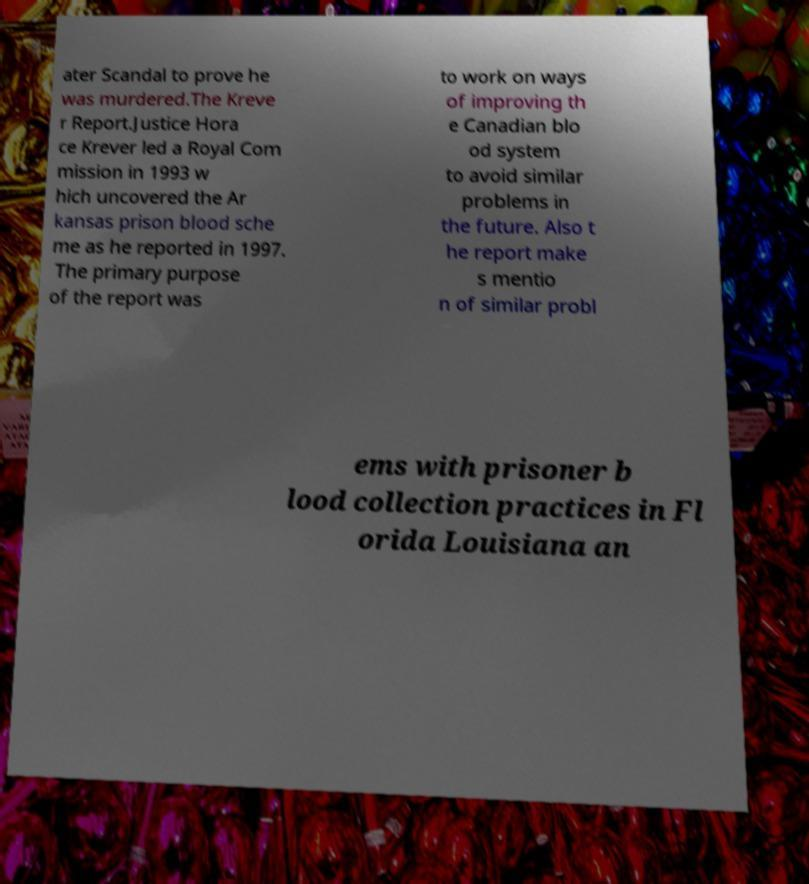Could you assist in decoding the text presented in this image and type it out clearly? ater Scandal to prove he was murdered.The Kreve r Report.Justice Hora ce Krever led a Royal Com mission in 1993 w hich uncovered the Ar kansas prison blood sche me as he reported in 1997. The primary purpose of the report was to work on ways of improving th e Canadian blo od system to avoid similar problems in the future. Also t he report make s mentio n of similar probl ems with prisoner b lood collection practices in Fl orida Louisiana an 